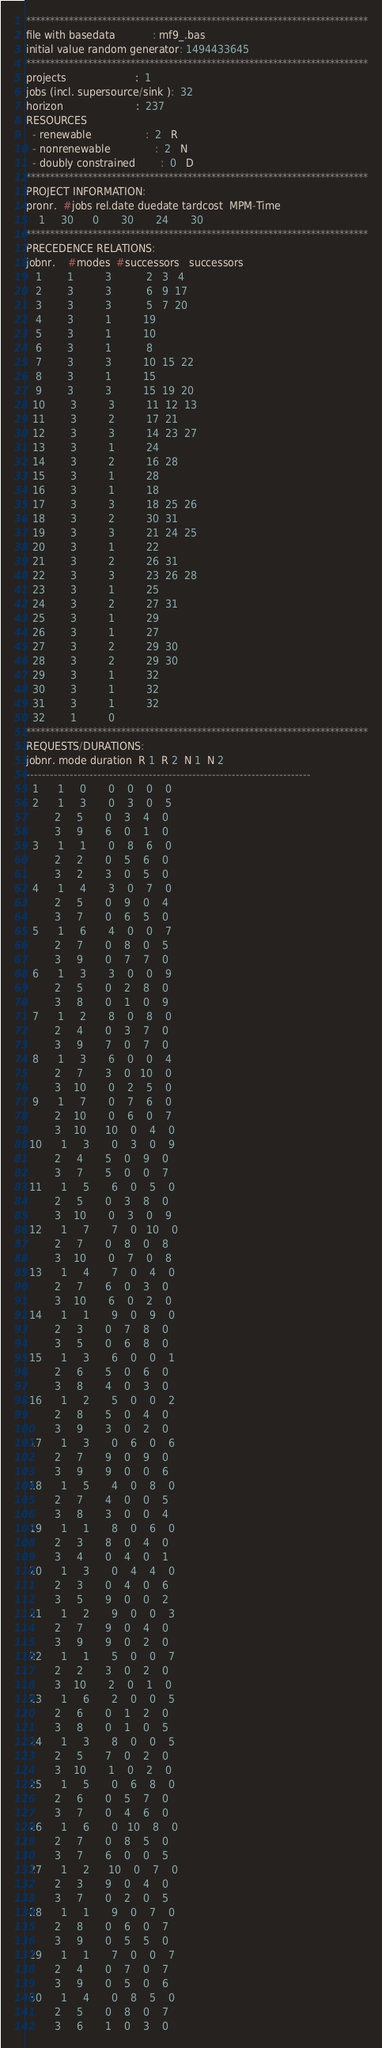<code> <loc_0><loc_0><loc_500><loc_500><_ObjectiveC_>************************************************************************
file with basedata            : mf9_.bas
initial value random generator: 1494433645
************************************************************************
projects                      :  1
jobs (incl. supersource/sink ):  32
horizon                       :  237
RESOURCES
  - renewable                 :  2   R
  - nonrenewable              :  2   N
  - doubly constrained        :  0   D
************************************************************************
PROJECT INFORMATION:
pronr.  #jobs rel.date duedate tardcost  MPM-Time
    1     30      0       30       24       30
************************************************************************
PRECEDENCE RELATIONS:
jobnr.    #modes  #successors   successors
   1        1          3           2   3   4
   2        3          3           6   9  17
   3        3          3           5   7  20
   4        3          1          19
   5        3          1          10
   6        3          1           8
   7        3          3          10  15  22
   8        3          1          15
   9        3          3          15  19  20
  10        3          3          11  12  13
  11        3          2          17  21
  12        3          3          14  23  27
  13        3          1          24
  14        3          2          16  28
  15        3          1          28
  16        3          1          18
  17        3          3          18  25  26
  18        3          2          30  31
  19        3          3          21  24  25
  20        3          1          22
  21        3          2          26  31
  22        3          3          23  26  28
  23        3          1          25
  24        3          2          27  31
  25        3          1          29
  26        3          1          27
  27        3          2          29  30
  28        3          2          29  30
  29        3          1          32
  30        3          1          32
  31        3          1          32
  32        1          0        
************************************************************************
REQUESTS/DURATIONS:
jobnr. mode duration  R 1  R 2  N 1  N 2
------------------------------------------------------------------------
  1      1     0       0    0    0    0
  2      1     3       0    3    0    5
         2     5       0    3    4    0
         3     9       6    0    1    0
  3      1     1       0    8    6    0
         2     2       0    5    6    0
         3     2       3    0    5    0
  4      1     4       3    0    7    0
         2     5       0    9    0    4
         3     7       0    6    5    0
  5      1     6       4    0    0    7
         2     7       0    8    0    5
         3     9       0    7    7    0
  6      1     3       3    0    0    9
         2     5       0    2    8    0
         3     8       0    1    0    9
  7      1     2       8    0    8    0
         2     4       0    3    7    0
         3     9       7    0    7    0
  8      1     3       6    0    0    4
         2     7       3    0   10    0
         3    10       0    2    5    0
  9      1     7       0    7    6    0
         2    10       0    6    0    7
         3    10      10    0    4    0
 10      1     3       0    3    0    9
         2     4       5    0    9    0
         3     7       5    0    0    7
 11      1     5       6    0    5    0
         2     5       0    3    8    0
         3    10       0    3    0    9
 12      1     7       7    0   10    0
         2     7       0    8    0    8
         3    10       0    7    0    8
 13      1     4       7    0    4    0
         2     7       6    0    3    0
         3    10       6    0    2    0
 14      1     1       9    0    9    0
         2     3       0    7    8    0
         3     5       0    6    8    0
 15      1     3       6    0    0    1
         2     6       5    0    6    0
         3     8       4    0    3    0
 16      1     2       5    0    0    2
         2     8       5    0    4    0
         3     9       3    0    2    0
 17      1     3       0    6    0    6
         2     7       9    0    9    0
         3     9       9    0    0    6
 18      1     5       4    0    8    0
         2     7       4    0    0    5
         3     8       3    0    0    4
 19      1     1       8    0    6    0
         2     3       8    0    4    0
         3     4       0    4    0    1
 20      1     3       0    4    4    0
         2     3       0    4    0    6
         3     5       9    0    0    2
 21      1     2       9    0    0    3
         2     7       9    0    4    0
         3     9       9    0    2    0
 22      1     1       5    0    0    7
         2     2       3    0    2    0
         3    10       2    0    1    0
 23      1     6       2    0    0    5
         2     6       0    1    2    0
         3     8       0    1    0    5
 24      1     3       8    0    0    5
         2     5       7    0    2    0
         3    10       1    0    2    0
 25      1     5       0    6    8    0
         2     6       0    5    7    0
         3     7       0    4    6    0
 26      1     6       0   10    8    0
         2     7       0    8    5    0
         3     7       6    0    0    5
 27      1     2      10    0    7    0
         2     3       9    0    4    0
         3     7       0    2    0    5
 28      1     1       9    0    7    0
         2     8       0    6    0    7
         3     9       0    5    5    0
 29      1     1       7    0    0    7
         2     4       0    7    0    7
         3     9       0    5    0    6
 30      1     4       0    8    5    0
         2     5       0    8    0    7
         3     6       1    0    3    0</code> 